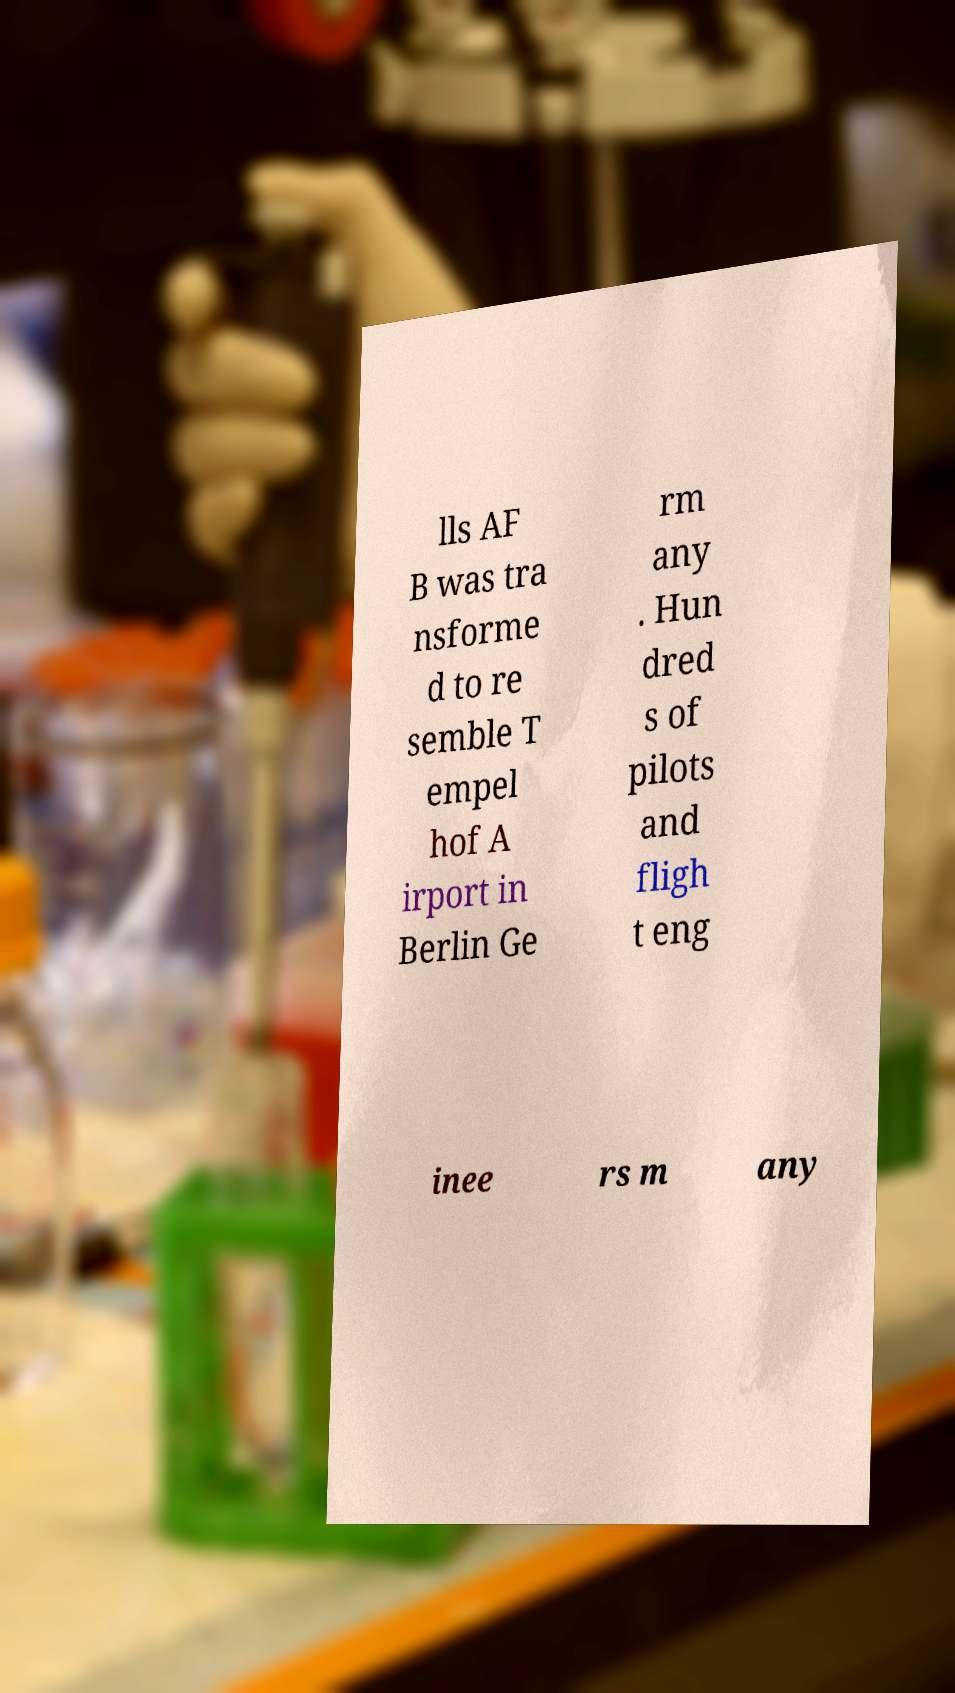Can you read and provide the text displayed in the image?This photo seems to have some interesting text. Can you extract and type it out for me? lls AF B was tra nsforme d to re semble T empel hof A irport in Berlin Ge rm any . Hun dred s of pilots and fligh t eng inee rs m any 